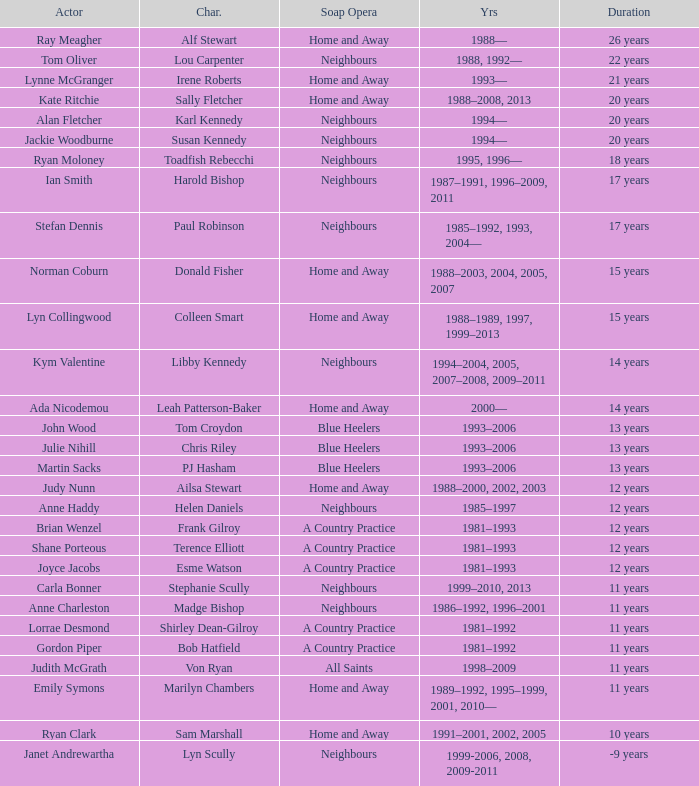Which years did Martin Sacks work on a soap opera? 1993–2006. 